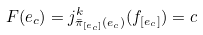<formula> <loc_0><loc_0><loc_500><loc_500>F ( e _ { c } ) = j ^ { k } _ { \bar { \pi } _ { [ e _ { c } ] } ( e _ { c } ) } ( f _ { [ e _ { c } ] } ) = c</formula> 